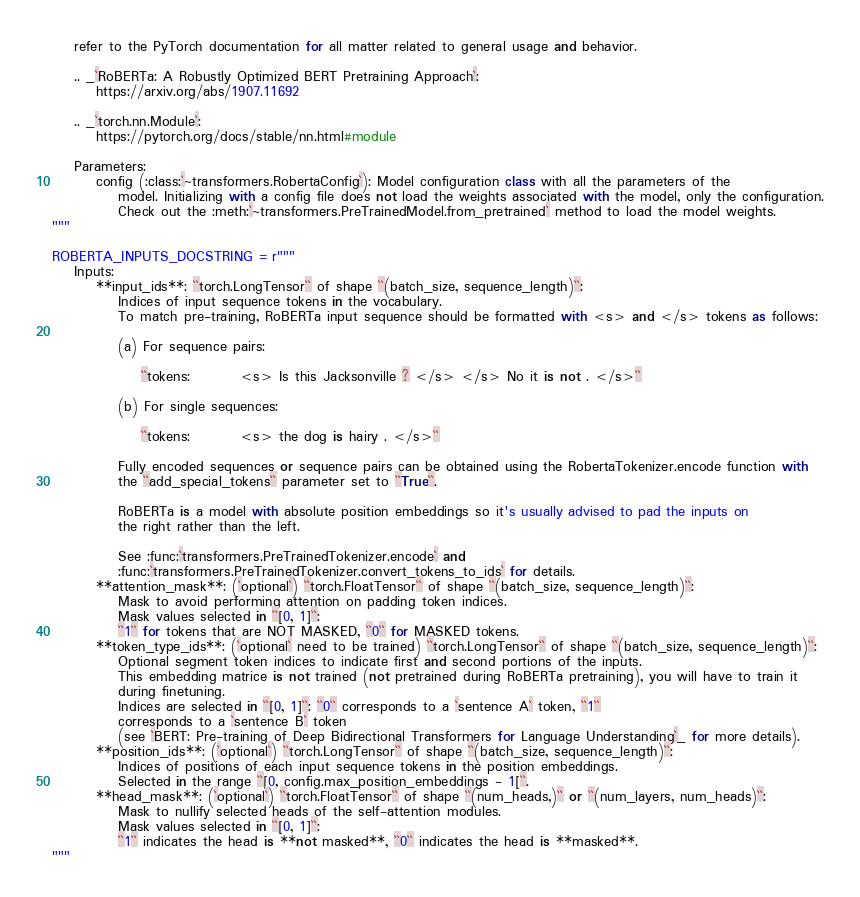Convert code to text. <code><loc_0><loc_0><loc_500><loc_500><_Python_>    refer to the PyTorch documentation for all matter related to general usage and behavior.

    .. _`RoBERTa: A Robustly Optimized BERT Pretraining Approach`:
        https://arxiv.org/abs/1907.11692

    .. _`torch.nn.Module`:
        https://pytorch.org/docs/stable/nn.html#module

    Parameters:
        config (:class:`~transformers.RobertaConfig`): Model configuration class with all the parameters of the 
            model. Initializing with a config file does not load the weights associated with the model, only the configuration.
            Check out the :meth:`~transformers.PreTrainedModel.from_pretrained` method to load the model weights.
"""

ROBERTA_INPUTS_DOCSTRING = r"""
    Inputs:
        **input_ids**: ``torch.LongTensor`` of shape ``(batch_size, sequence_length)``:
            Indices of input sequence tokens in the vocabulary.
            To match pre-training, RoBERTa input sequence should be formatted with <s> and </s> tokens as follows:

            (a) For sequence pairs:

                ``tokens:         <s> Is this Jacksonville ? </s> </s> No it is not . </s>``

            (b) For single sequences:

                ``tokens:         <s> the dog is hairy . </s>``

            Fully encoded sequences or sequence pairs can be obtained using the RobertaTokenizer.encode function with 
            the ``add_special_tokens`` parameter set to ``True``.

            RoBERTa is a model with absolute position embeddings so it's usually advised to pad the inputs on
            the right rather than the left.

            See :func:`transformers.PreTrainedTokenizer.encode` and
            :func:`transformers.PreTrainedTokenizer.convert_tokens_to_ids` for details.
        **attention_mask**: (`optional`) ``torch.FloatTensor`` of shape ``(batch_size, sequence_length)``:
            Mask to avoid performing attention on padding token indices.
            Mask values selected in ``[0, 1]``:
            ``1`` for tokens that are NOT MASKED, ``0`` for MASKED tokens.
        **token_type_ids**: (`optional` need to be trained) ``torch.LongTensor`` of shape ``(batch_size, sequence_length)``:
            Optional segment token indices to indicate first and second portions of the inputs.
            This embedding matrice is not trained (not pretrained during RoBERTa pretraining), you will have to train it
            during finetuning.
            Indices are selected in ``[0, 1]``: ``0`` corresponds to a `sentence A` token, ``1``
            corresponds to a `sentence B` token
            (see `BERT: Pre-training of Deep Bidirectional Transformers for Language Understanding`_ for more details).
        **position_ids**: (`optional`) ``torch.LongTensor`` of shape ``(batch_size, sequence_length)``:
            Indices of positions of each input sequence tokens in the position embeddings.
            Selected in the range ``[0, config.max_position_embeddings - 1[``.
        **head_mask**: (`optional`) ``torch.FloatTensor`` of shape ``(num_heads,)`` or ``(num_layers, num_heads)``:
            Mask to nullify selected heads of the self-attention modules.
            Mask values selected in ``[0, 1]``:
            ``1`` indicates the head is **not masked**, ``0`` indicates the head is **masked**.
"""
</code> 